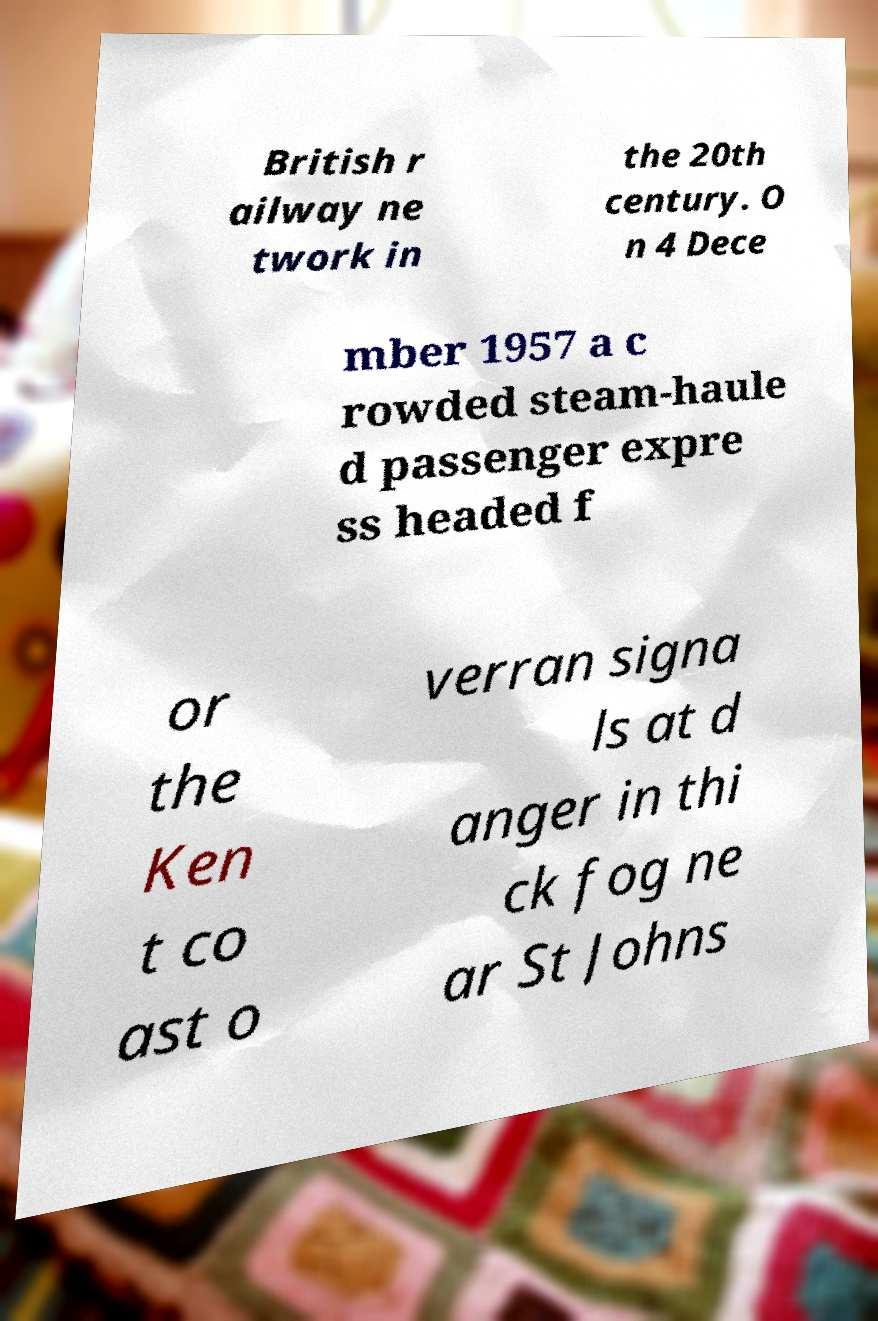There's text embedded in this image that I need extracted. Can you transcribe it verbatim? British r ailway ne twork in the 20th century. O n 4 Dece mber 1957 a c rowded steam-haule d passenger expre ss headed f or the Ken t co ast o verran signa ls at d anger in thi ck fog ne ar St Johns 